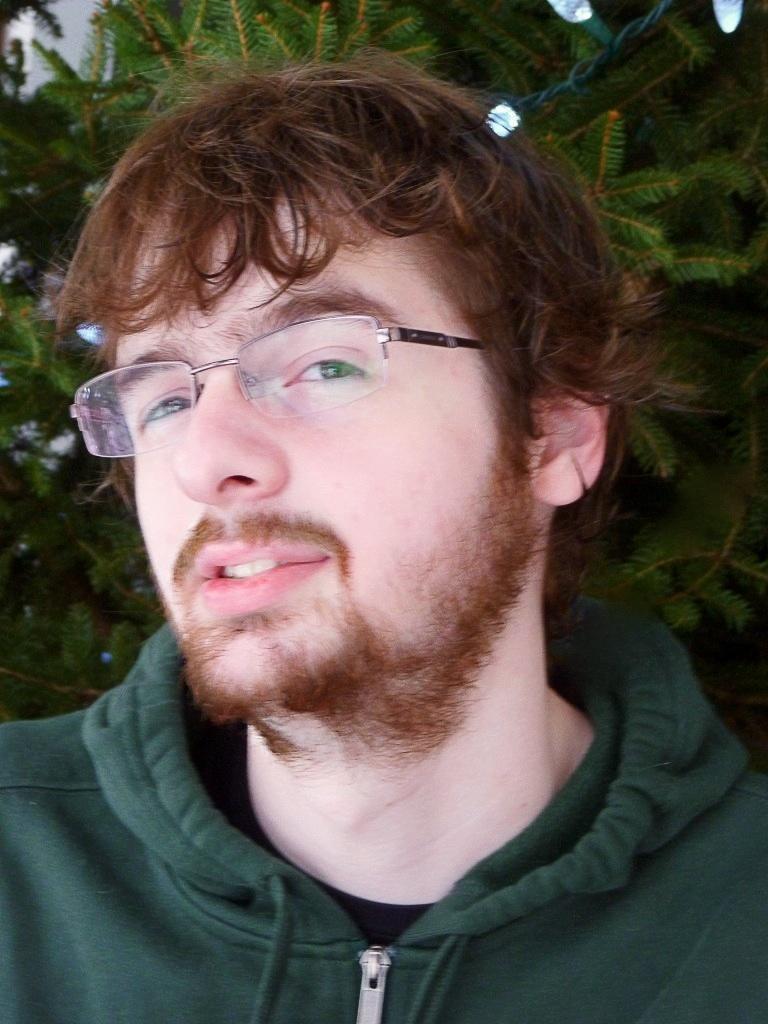Describe this image in one or two sentences. In this image there is a man he is wearing green color sweater, in the background there is a tree. 